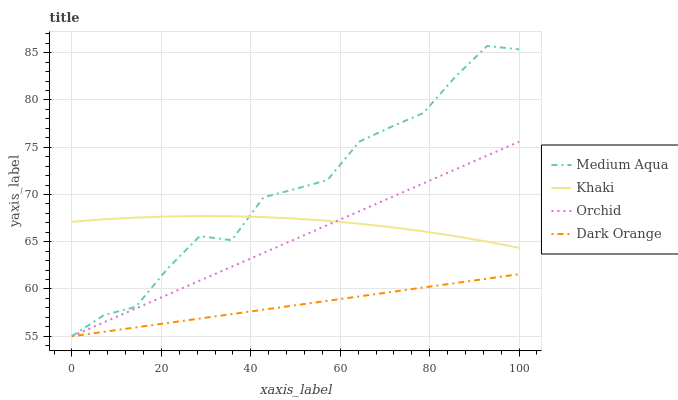Does Dark Orange have the minimum area under the curve?
Answer yes or no. Yes. Does Medium Aqua have the maximum area under the curve?
Answer yes or no. Yes. Does Khaki have the minimum area under the curve?
Answer yes or no. No. Does Khaki have the maximum area under the curve?
Answer yes or no. No. Is Dark Orange the smoothest?
Answer yes or no. Yes. Is Medium Aqua the roughest?
Answer yes or no. Yes. Is Khaki the smoothest?
Answer yes or no. No. Is Khaki the roughest?
Answer yes or no. No. Does Dark Orange have the lowest value?
Answer yes or no. Yes. Does Khaki have the lowest value?
Answer yes or no. No. Does Medium Aqua have the highest value?
Answer yes or no. Yes. Does Khaki have the highest value?
Answer yes or no. No. Is Dark Orange less than Khaki?
Answer yes or no. Yes. Is Khaki greater than Dark Orange?
Answer yes or no. Yes. Does Medium Aqua intersect Dark Orange?
Answer yes or no. Yes. Is Medium Aqua less than Dark Orange?
Answer yes or no. No. Is Medium Aqua greater than Dark Orange?
Answer yes or no. No. Does Dark Orange intersect Khaki?
Answer yes or no. No. 